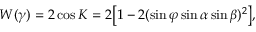Convert formula to latex. <formula><loc_0><loc_0><loc_500><loc_500>W ( \gamma ) = 2 \cos K = 2 \left [ 1 - 2 ( \sin \varphi \sin \alpha \sin \beta ) ^ { 2 } \right ] ,</formula> 